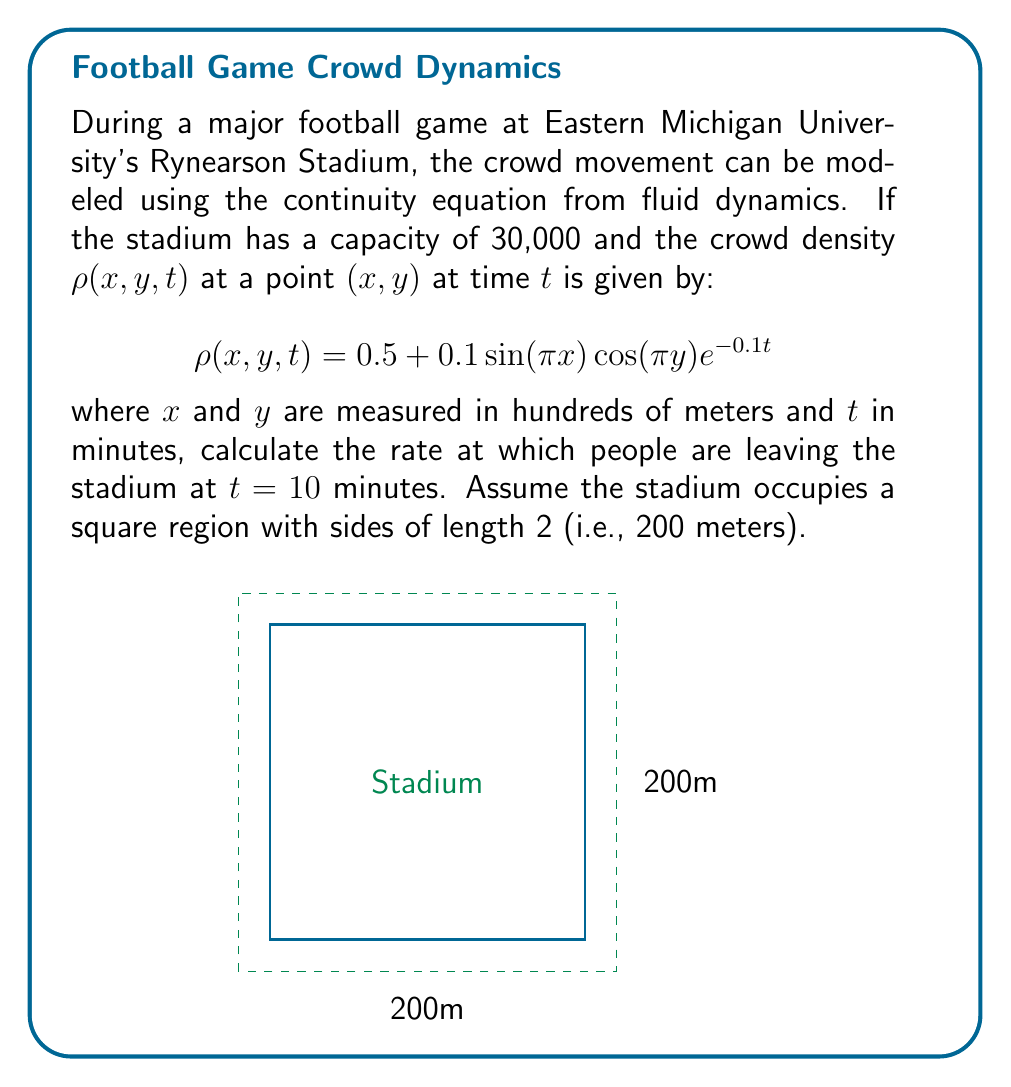Solve this math problem. To solve this problem, we'll use the continuity equation and the divergence theorem:

1) The continuity equation in 2D is:
   $$\frac{\partial \rho}{\partial t} + \nabla \cdot (\rho \mathbf{v}) = 0$$
   where $\mathbf{v}$ is the velocity field.

2) Integrating over the area $A$ of the stadium:
   $$\int_A \frac{\partial \rho}{\partial t} dA + \int_A \nabla \cdot (\rho \mathbf{v}) dA = 0$$

3) Using the divergence theorem, the second integral becomes a line integral around the boundary:
   $$\int_A \frac{\partial \rho}{\partial t} dA + \oint_{\partial A} \rho \mathbf{v} \cdot \mathbf{n} ds = 0$$

4) The second term represents the flow out of the stadium. Let's call this outflow $Q$:
   $$Q = -\int_A \frac{\partial \rho}{\partial t} dA$$

5) Now, we need to calculate $\frac{\partial \rho}{\partial t}$:
   $$\frac{\partial \rho}{\partial t} = -0.01\sin(\pi x)\cos(\pi y)e^{-0.1t}$$

6) At $t=10$:
   $$\frac{\partial \rho}{\partial t} = -0.01\sin(\pi x)\cos(\pi y)e^{-1}$$

7) Integrating over the area (from -1 to 1 in both x and y):
   $$Q = 0.01e^{-1} \int_{-1}^1 \int_{-1}^1 \sin(\pi x)\cos(\pi y) dx dy$$

8) Solving this double integral:
   $$Q = 0.01e^{-1} \cdot \frac{4}{\pi^2} = \frac{0.04}{\pi^2 e} \approx 0.00149$$

9) This represents the rate at which the density is decreasing. To get the number of people, we multiply by the area (4 square hundreds of meters or 40,000 square meters):
   $$Q_{people} = 0.00149 \cdot 40000 \approx 59.6$$
Answer: Approximately 60 people per minute 